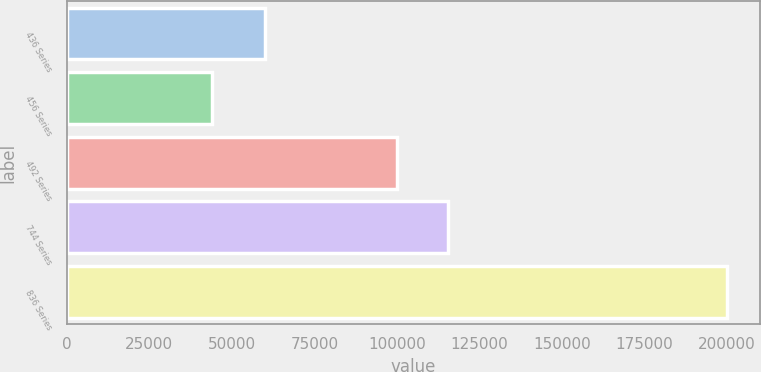<chart> <loc_0><loc_0><loc_500><loc_500><bar_chart><fcel>436 Series<fcel>456 Series<fcel>492 Series<fcel>744 Series<fcel>836 Series<nl><fcel>59920<fcel>43887<fcel>100000<fcel>115611<fcel>200000<nl></chart> 